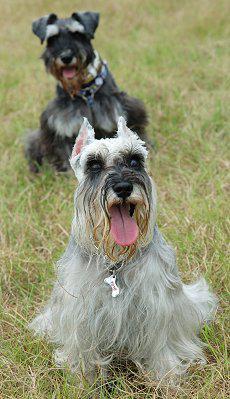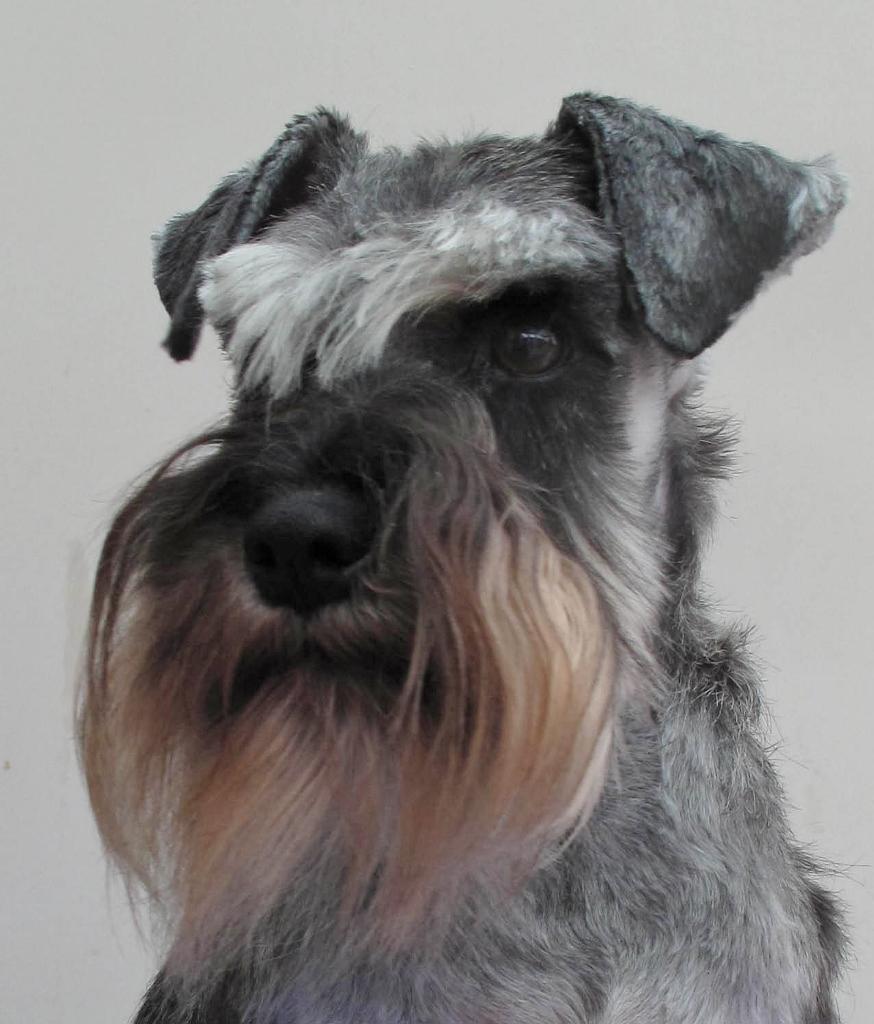The first image is the image on the left, the second image is the image on the right. Analyze the images presented: Is the assertion "Some type of animal figure is behind a forward-turned schnauzer dog in the left image." valid? Answer yes or no. Yes. The first image is the image on the left, the second image is the image on the right. Considering the images on both sides, is "At least one of the dogs has its mouth open." valid? Answer yes or no. Yes. 